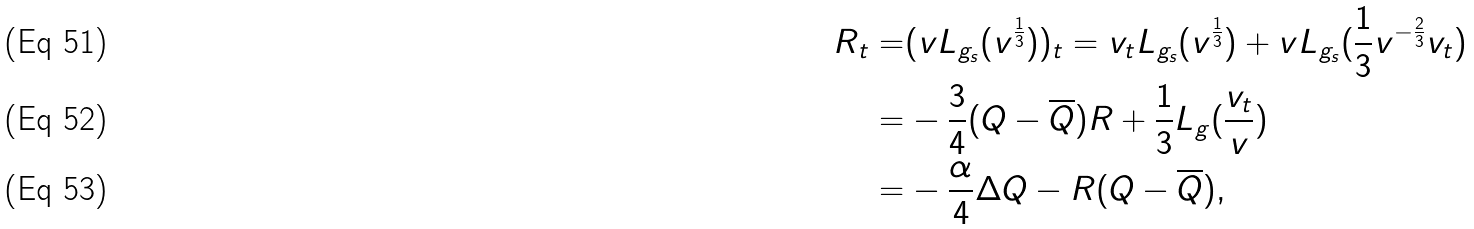Convert formula to latex. <formula><loc_0><loc_0><loc_500><loc_500>R _ { t } = & ( v L _ { g _ { s } } ( v ^ { \frac { 1 } { 3 } } ) ) _ { t } = v _ { t } L _ { g _ { s } } ( v ^ { \frac { 1 } { 3 } } ) + v L _ { g _ { s } } ( \frac { 1 } { 3 } v ^ { - \frac { 2 } { 3 } } v _ { t } ) \\ = & - \frac { 3 } { 4 } ( Q - \overline { Q } ) R + \frac { 1 } { 3 } L _ { g } ( \frac { v _ { t } } { v } ) \\ = & - \frac { \alpha } { 4 } \Delta Q - R ( Q - \overline { Q } ) ,</formula> 